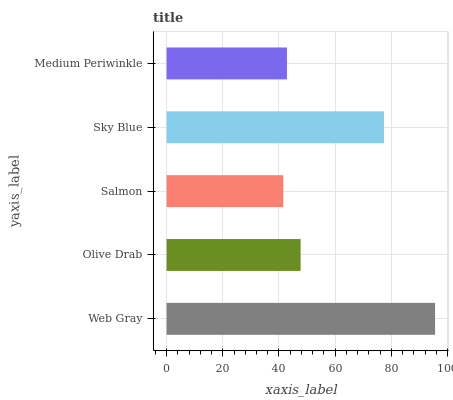Is Salmon the minimum?
Answer yes or no. Yes. Is Web Gray the maximum?
Answer yes or no. Yes. Is Olive Drab the minimum?
Answer yes or no. No. Is Olive Drab the maximum?
Answer yes or no. No. Is Web Gray greater than Olive Drab?
Answer yes or no. Yes. Is Olive Drab less than Web Gray?
Answer yes or no. Yes. Is Olive Drab greater than Web Gray?
Answer yes or no. No. Is Web Gray less than Olive Drab?
Answer yes or no. No. Is Olive Drab the high median?
Answer yes or no. Yes. Is Olive Drab the low median?
Answer yes or no. Yes. Is Sky Blue the high median?
Answer yes or no. No. Is Sky Blue the low median?
Answer yes or no. No. 